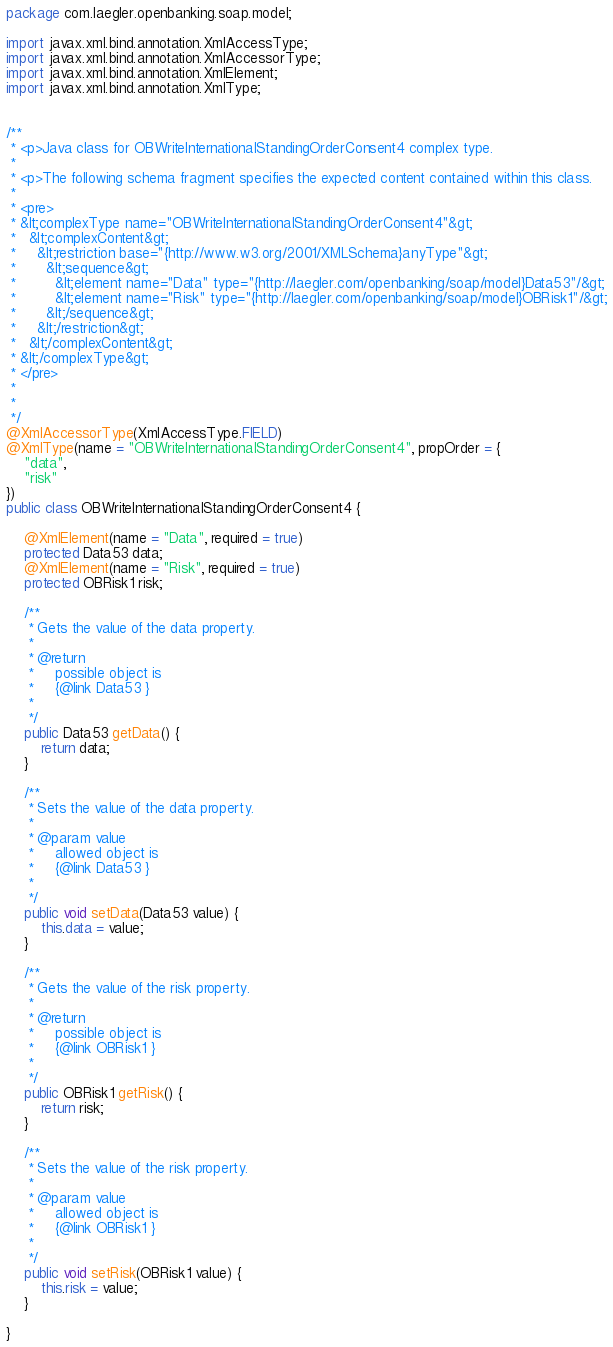<code> <loc_0><loc_0><loc_500><loc_500><_Java_>
package com.laegler.openbanking.soap.model;

import javax.xml.bind.annotation.XmlAccessType;
import javax.xml.bind.annotation.XmlAccessorType;
import javax.xml.bind.annotation.XmlElement;
import javax.xml.bind.annotation.XmlType;


/**
 * <p>Java class for OBWriteInternationalStandingOrderConsent4 complex type.
 * 
 * <p>The following schema fragment specifies the expected content contained within this class.
 * 
 * <pre>
 * &lt;complexType name="OBWriteInternationalStandingOrderConsent4"&gt;
 *   &lt;complexContent&gt;
 *     &lt;restriction base="{http://www.w3.org/2001/XMLSchema}anyType"&gt;
 *       &lt;sequence&gt;
 *         &lt;element name="Data" type="{http://laegler.com/openbanking/soap/model}Data53"/&gt;
 *         &lt;element name="Risk" type="{http://laegler.com/openbanking/soap/model}OBRisk1"/&gt;
 *       &lt;/sequence&gt;
 *     &lt;/restriction&gt;
 *   &lt;/complexContent&gt;
 * &lt;/complexType&gt;
 * </pre>
 * 
 * 
 */
@XmlAccessorType(XmlAccessType.FIELD)
@XmlType(name = "OBWriteInternationalStandingOrderConsent4", propOrder = {
    "data",
    "risk"
})
public class OBWriteInternationalStandingOrderConsent4 {

    @XmlElement(name = "Data", required = true)
    protected Data53 data;
    @XmlElement(name = "Risk", required = true)
    protected OBRisk1 risk;

    /**
     * Gets the value of the data property.
     * 
     * @return
     *     possible object is
     *     {@link Data53 }
     *     
     */
    public Data53 getData() {
        return data;
    }

    /**
     * Sets the value of the data property.
     * 
     * @param value
     *     allowed object is
     *     {@link Data53 }
     *     
     */
    public void setData(Data53 value) {
        this.data = value;
    }

    /**
     * Gets the value of the risk property.
     * 
     * @return
     *     possible object is
     *     {@link OBRisk1 }
     *     
     */
    public OBRisk1 getRisk() {
        return risk;
    }

    /**
     * Sets the value of the risk property.
     * 
     * @param value
     *     allowed object is
     *     {@link OBRisk1 }
     *     
     */
    public void setRisk(OBRisk1 value) {
        this.risk = value;
    }

}
</code> 